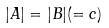Convert formula to latex. <formula><loc_0><loc_0><loc_500><loc_500>| A | = | B | ( = c )</formula> 